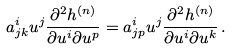<formula> <loc_0><loc_0><loc_500><loc_500>a ^ { i } _ { j k } u ^ { j } \frac { \partial ^ { 2 } h ^ { ( n ) } } { \partial u ^ { i } \partial u ^ { p } } = a ^ { i } _ { j p } u ^ { j } \frac { \partial ^ { 2 } h ^ { ( n ) } } { \partial u ^ { i } \partial u ^ { k } } \, .</formula> 